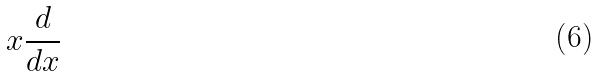<formula> <loc_0><loc_0><loc_500><loc_500>x \frac { d } { d x }</formula> 